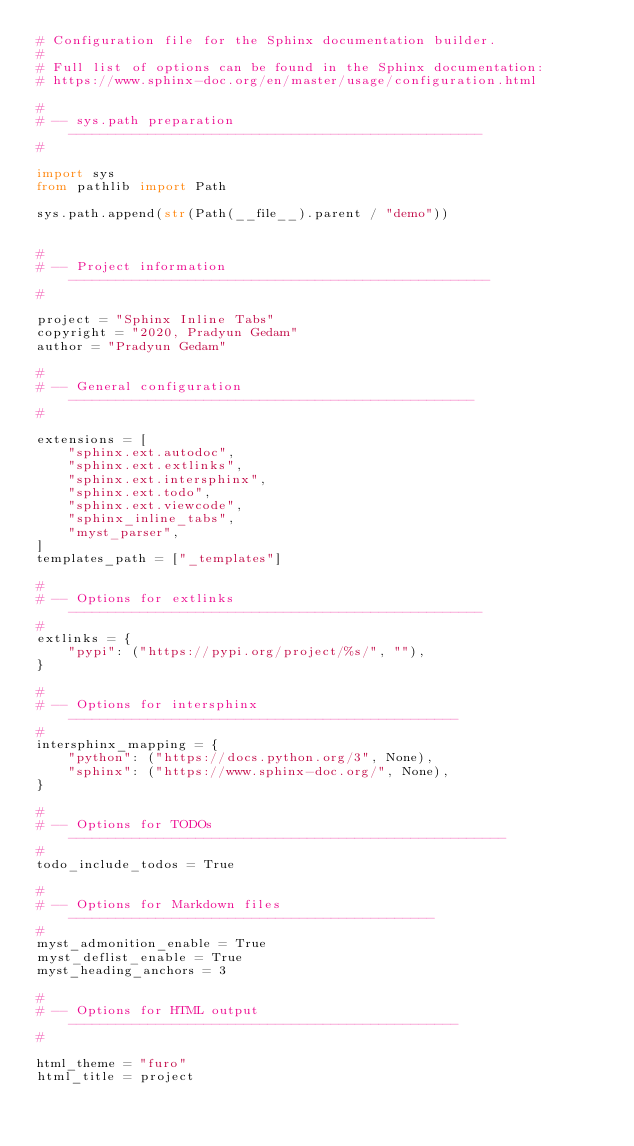<code> <loc_0><loc_0><loc_500><loc_500><_Python_># Configuration file for the Sphinx documentation builder.
#
# Full list of options can be found in the Sphinx documentation:
# https://www.sphinx-doc.org/en/master/usage/configuration.html

#
# -- sys.path preparation ----------------------------------------------------
#

import sys
from pathlib import Path

sys.path.append(str(Path(__file__).parent / "demo"))


#
# -- Project information -----------------------------------------------------
#

project = "Sphinx Inline Tabs"
copyright = "2020, Pradyun Gedam"
author = "Pradyun Gedam"

#
# -- General configuration ---------------------------------------------------
#

extensions = [
    "sphinx.ext.autodoc",
    "sphinx.ext.extlinks",
    "sphinx.ext.intersphinx",
    "sphinx.ext.todo",
    "sphinx.ext.viewcode",
    "sphinx_inline_tabs",
    "myst_parser",
]
templates_path = ["_templates"]

#
# -- Options for extlinks ----------------------------------------------------
#
extlinks = {
    "pypi": ("https://pypi.org/project/%s/", ""),
}

#
# -- Options for intersphinx -------------------------------------------------
#
intersphinx_mapping = {
    "python": ("https://docs.python.org/3", None),
    "sphinx": ("https://www.sphinx-doc.org/", None),
}

#
# -- Options for TODOs -------------------------------------------------------
#
todo_include_todos = True

#
# -- Options for Markdown files ----------------------------------------------
#
myst_admonition_enable = True
myst_deflist_enable = True
myst_heading_anchors = 3

#
# -- Options for HTML output -------------------------------------------------
#

html_theme = "furo"
html_title = project
</code> 